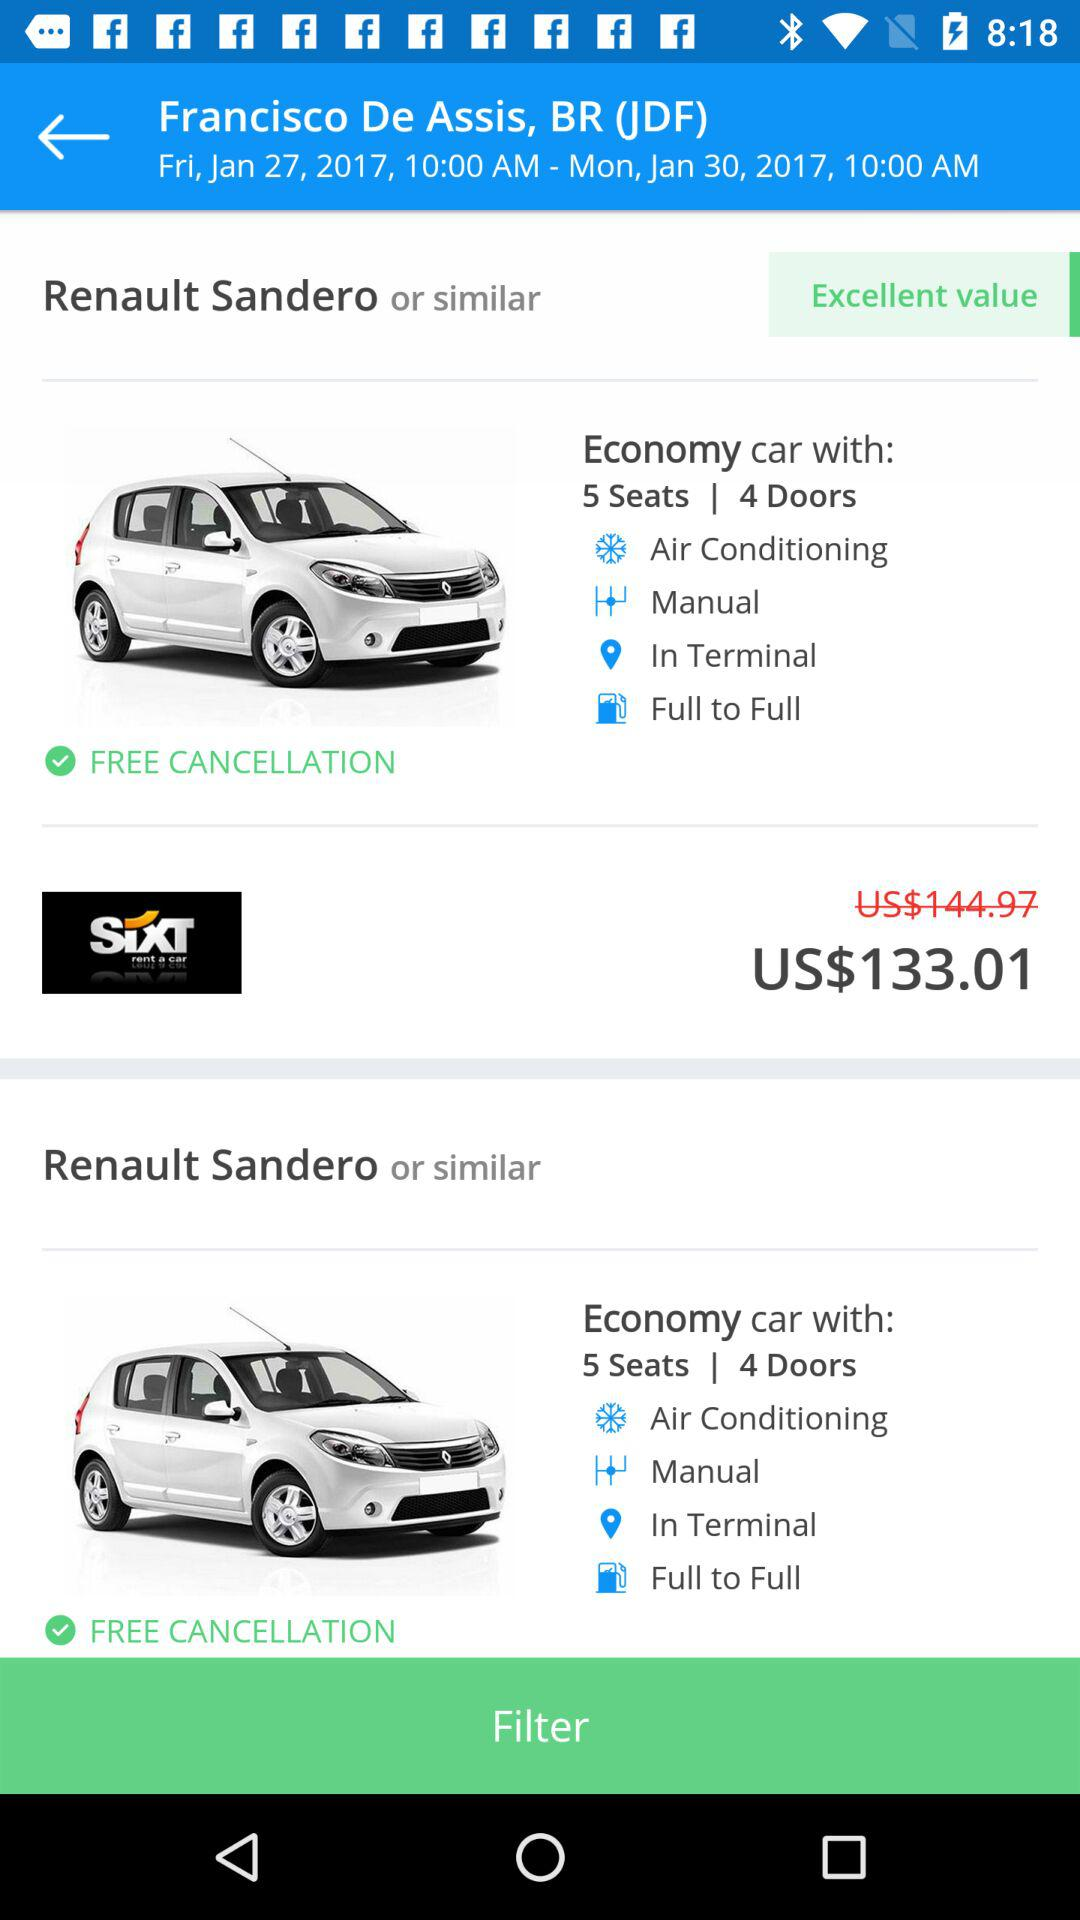What was the original price of the car? The original price of the car was US$144.97. 